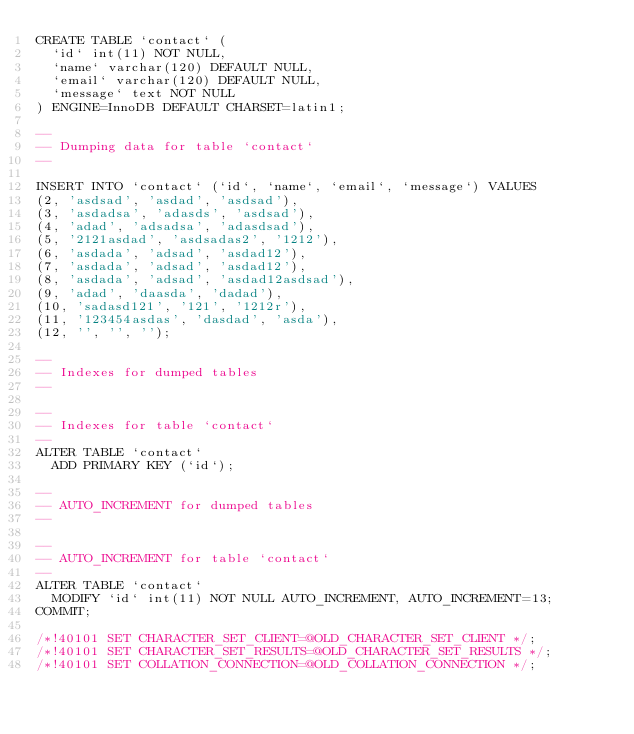<code> <loc_0><loc_0><loc_500><loc_500><_SQL_>CREATE TABLE `contact` (
  `id` int(11) NOT NULL,
  `name` varchar(120) DEFAULT NULL,
  `email` varchar(120) DEFAULT NULL,
  `message` text NOT NULL
) ENGINE=InnoDB DEFAULT CHARSET=latin1;

--
-- Dumping data for table `contact`
--

INSERT INTO `contact` (`id`, `name`, `email`, `message`) VALUES
(2, 'asdsad', 'asdad', 'asdsad'),
(3, 'asdadsa', 'adasds', 'asdsad'),
(4, 'adad', 'adsadsa', 'adasdsad'),
(5, '2121asdad', 'asdsadas2', '1212'),
(6, 'asdada', 'adsad', 'asdad12'),
(7, 'asdada', 'adsad', 'asdad12'),
(8, 'asdada', 'adsad', 'asdad12asdsad'),
(9, 'adad', 'daasda', 'dadad'),
(10, 'sadasd121', '121', '1212r'),
(11, '123454asdas', 'dasdad', 'asda'),
(12, '', '', '');

--
-- Indexes for dumped tables
--

--
-- Indexes for table `contact`
--
ALTER TABLE `contact`
  ADD PRIMARY KEY (`id`);

--
-- AUTO_INCREMENT for dumped tables
--

--
-- AUTO_INCREMENT for table `contact`
--
ALTER TABLE `contact`
  MODIFY `id` int(11) NOT NULL AUTO_INCREMENT, AUTO_INCREMENT=13;
COMMIT;

/*!40101 SET CHARACTER_SET_CLIENT=@OLD_CHARACTER_SET_CLIENT */;
/*!40101 SET CHARACTER_SET_RESULTS=@OLD_CHARACTER_SET_RESULTS */;
/*!40101 SET COLLATION_CONNECTION=@OLD_COLLATION_CONNECTION */;
</code> 